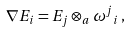<formula> <loc_0><loc_0><loc_500><loc_500>\nabla E _ { i } = E _ { j } \otimes _ { a } { \omega ^ { j } } _ { i } \, ,</formula> 